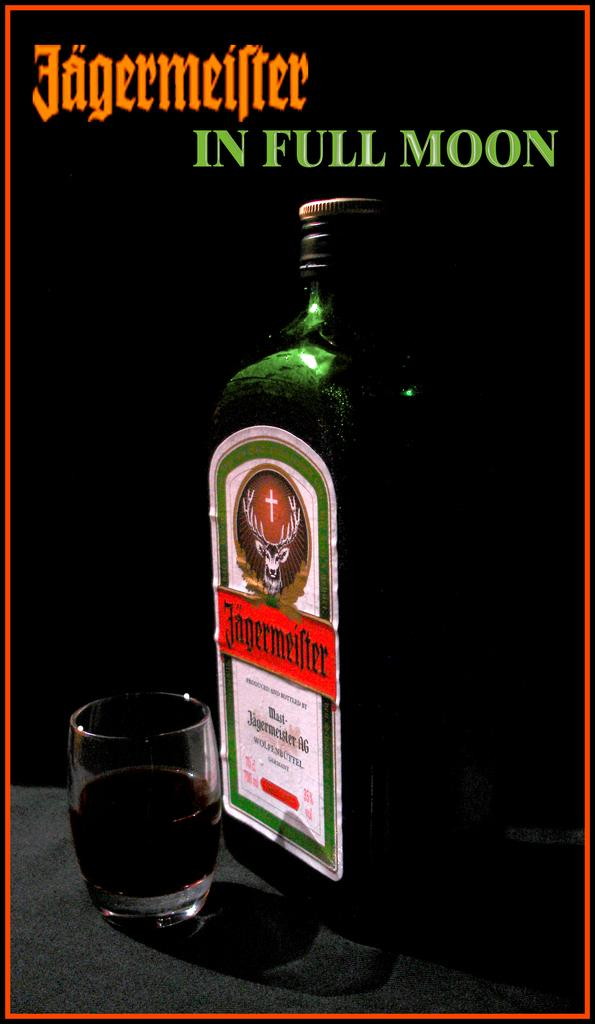<image>
Describe the image concisely. A bottle of jageemeister with a shot glass full of the alcohol. 